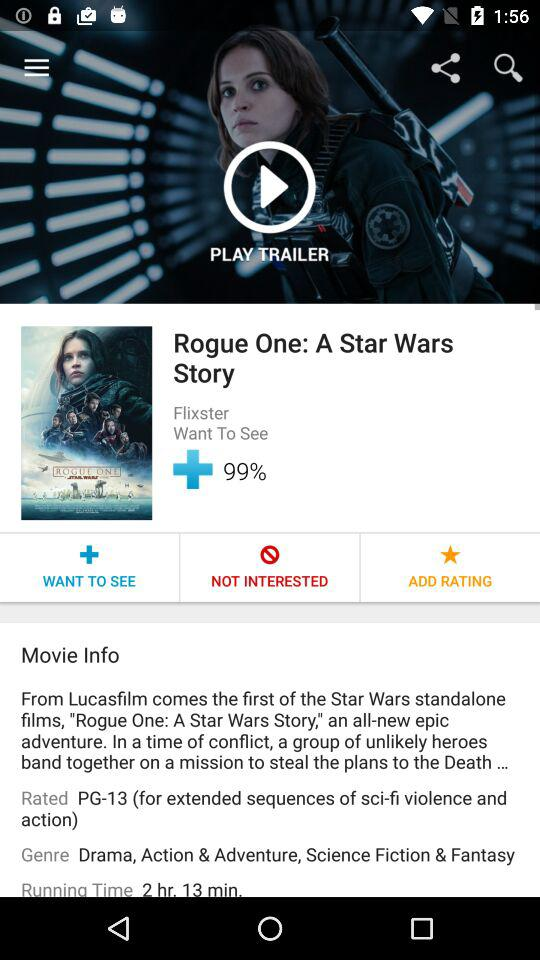How long is the movie? 2 hr. 13 min. 